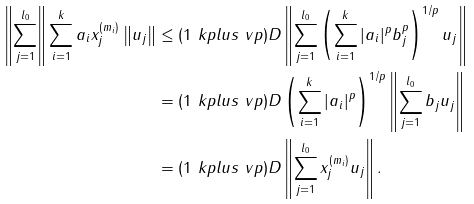Convert formula to latex. <formula><loc_0><loc_0><loc_500><loc_500>\left \| \sum _ { j = 1 } ^ { l _ { 0 } } \right \| \sum _ { i = 1 } ^ { k } a _ { i } x ^ { ( m _ { i } ) } _ { j } \left \| u _ { j } \right \| & \leq ( 1 \ k p l u s \ v p ) D \left \| \sum _ { j = 1 } ^ { l _ { 0 } } \left ( \sum _ { i = 1 } ^ { k } | a _ { i } | ^ { p } b _ { j } ^ { p } \right ) ^ { 1 / p } u _ { j } \right \| \\ & = ( 1 \ k p l u s \ v p ) D \left ( \sum _ { i = 1 } ^ { k } | a _ { i } | ^ { p } \right ) ^ { 1 / p } \left \| \sum _ { j = 1 } ^ { l _ { 0 } } b _ { j } u _ { j } \right \| \\ & = ( 1 \ k p l u s \ v p ) D \left \| \sum _ { j = 1 } ^ { l _ { 0 } } \| x ^ { ( m _ { i } ) } _ { j } \| u _ { j } \right \| .</formula> 